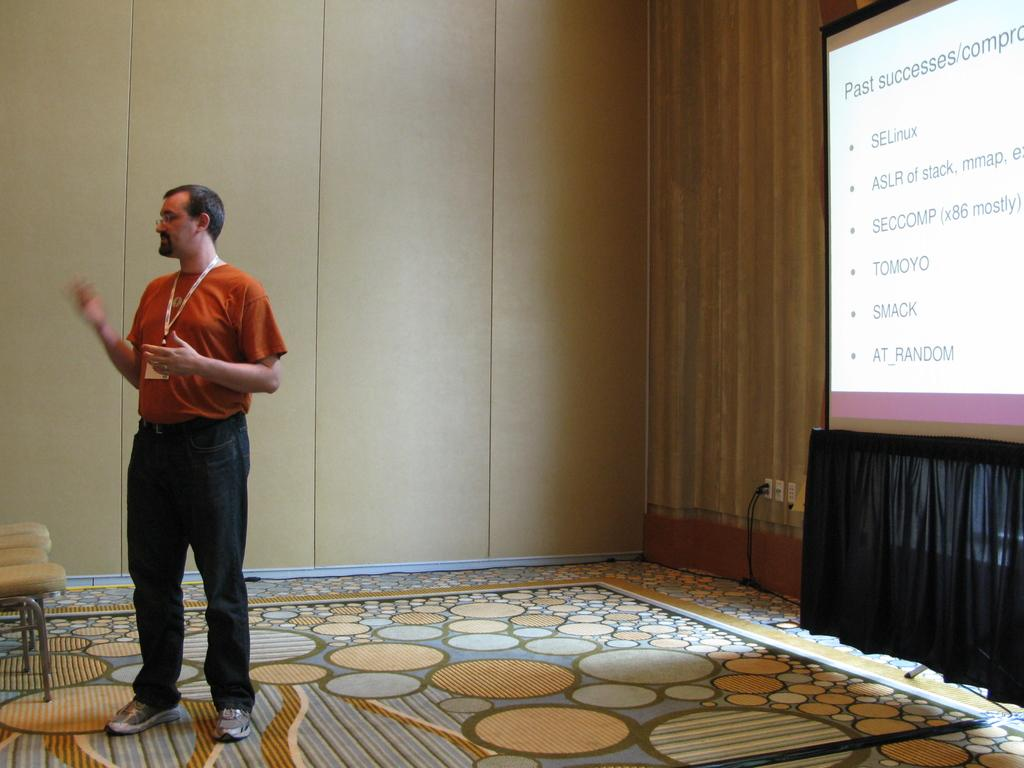What is the main subject in the image? There is a person standing in the image. What can be seen behind the person? There is a screen visible in the image. What might be used for connecting devices in the image? There are cables present in the image. What type of material is used for the wall in the image? There is a wooden wall in the image. What type of furniture is present in the image? There are chairs in the image. What type of animal can be seen pointing at the screen in the image? There is no animal present in the image, and no one is pointing at the screen. 